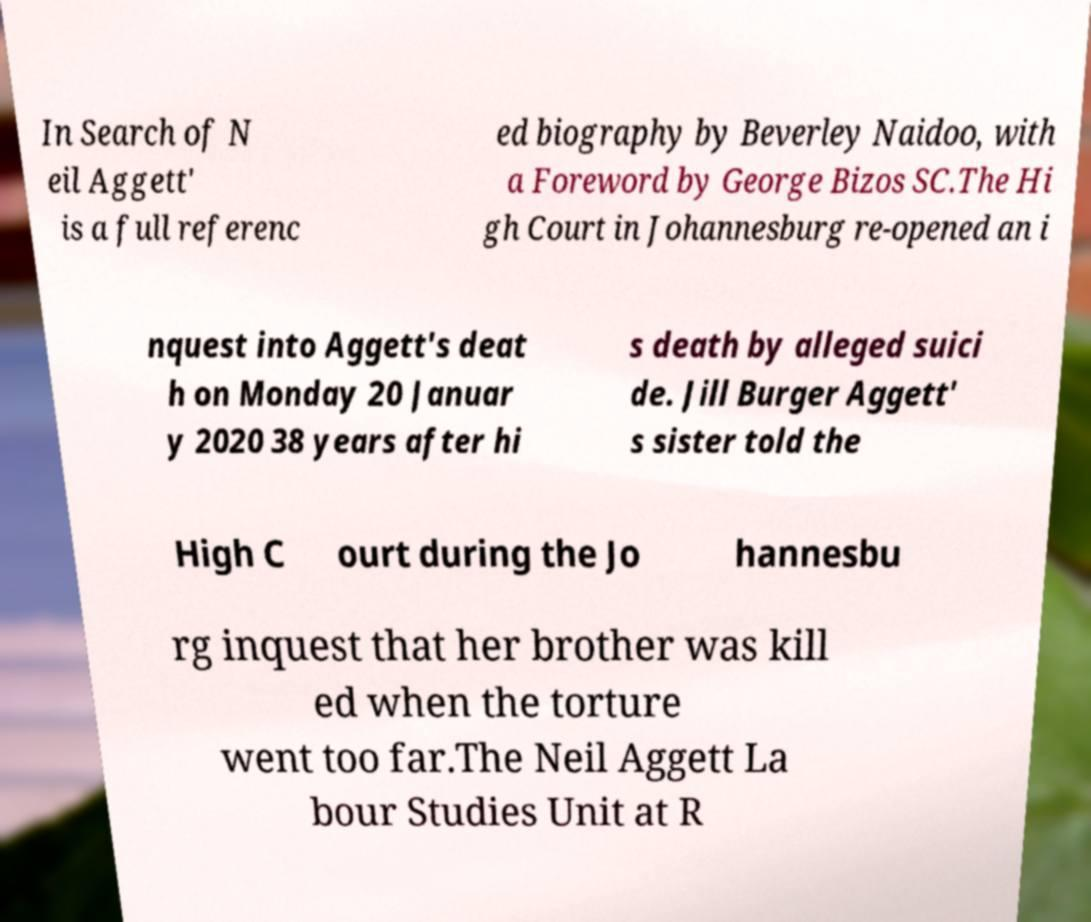I need the written content from this picture converted into text. Can you do that? In Search of N eil Aggett' is a full referenc ed biography by Beverley Naidoo, with a Foreword by George Bizos SC.The Hi gh Court in Johannesburg re-opened an i nquest into Aggett's deat h on Monday 20 Januar y 2020 38 years after hi s death by alleged suici de. Jill Burger Aggett' s sister told the High C ourt during the Jo hannesbu rg inquest that her brother was kill ed when the torture went too far.The Neil Aggett La bour Studies Unit at R 